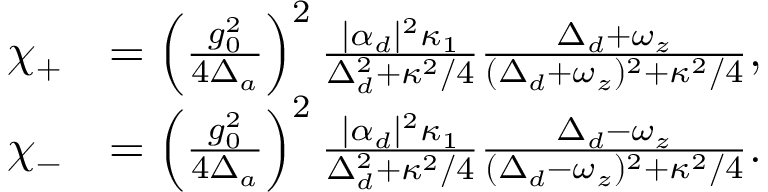Convert formula to latex. <formula><loc_0><loc_0><loc_500><loc_500>\begin{array} { r l } { \chi _ { + } } & { = \left ( \frac { g _ { 0 } ^ { 2 } } { 4 \Delta _ { a } } \right ) ^ { 2 } \frac { | \alpha _ { d } | ^ { 2 } \kappa _ { 1 } } { \Delta _ { d } ^ { 2 } + \kappa ^ { 2 } / 4 } \frac { \Delta _ { d } + \omega _ { z } } { ( \Delta _ { d } + \omega _ { z } ) ^ { 2 } + \kappa ^ { 2 } / 4 } , } \\ { \chi _ { - } } & { = \left ( \frac { g _ { 0 } ^ { 2 } } { 4 \Delta _ { a } } \right ) ^ { 2 } \frac { | \alpha _ { d } | ^ { 2 } \kappa _ { 1 } } { \Delta _ { d } ^ { 2 } + \kappa ^ { 2 } / 4 } \frac { \Delta _ { d } - \omega _ { z } } { ( \Delta _ { d } - \omega _ { z } ) ^ { 2 } + \kappa ^ { 2 } / 4 } . } \end{array}</formula> 